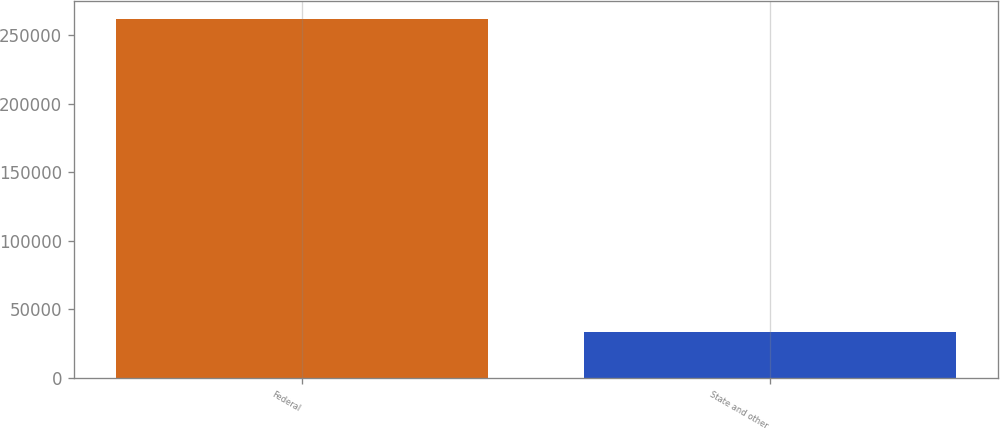Convert chart. <chart><loc_0><loc_0><loc_500><loc_500><bar_chart><fcel>Federal<fcel>State and other<nl><fcel>261921<fcel>33729<nl></chart> 